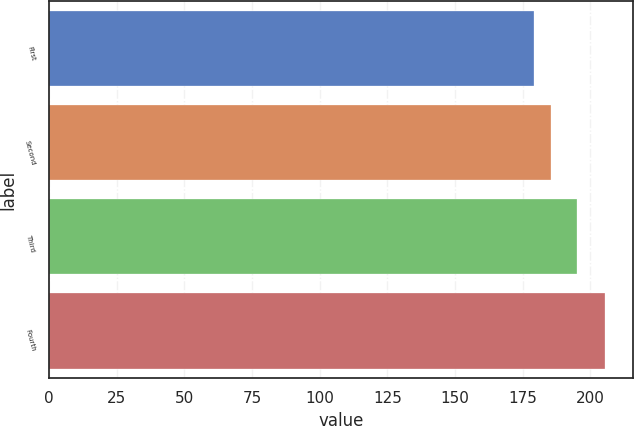Convert chart to OTSL. <chart><loc_0><loc_0><loc_500><loc_500><bar_chart><fcel>First<fcel>Second<fcel>Third<fcel>Fourth<nl><fcel>179.17<fcel>185.34<fcel>195.15<fcel>205.63<nl></chart> 